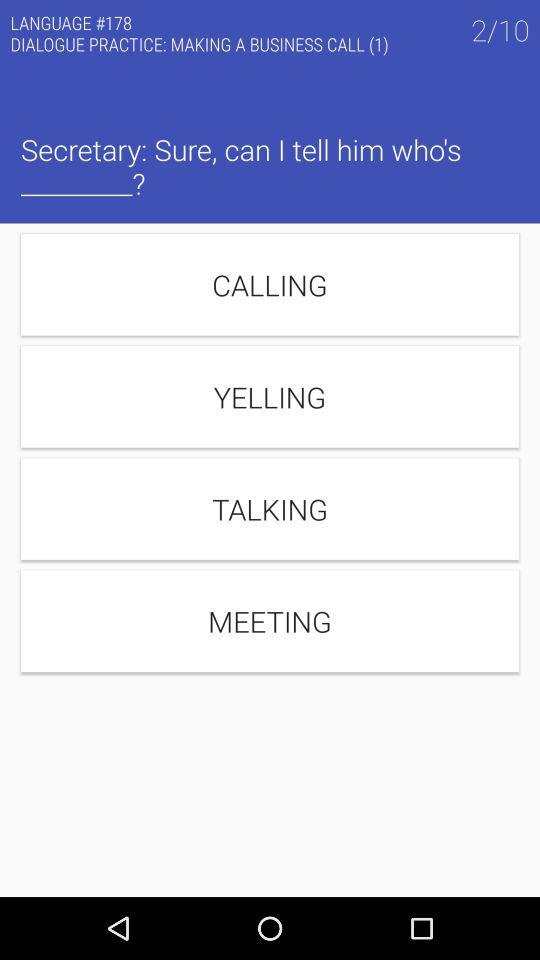How many questions in total are there? There are 10 questions in total. 